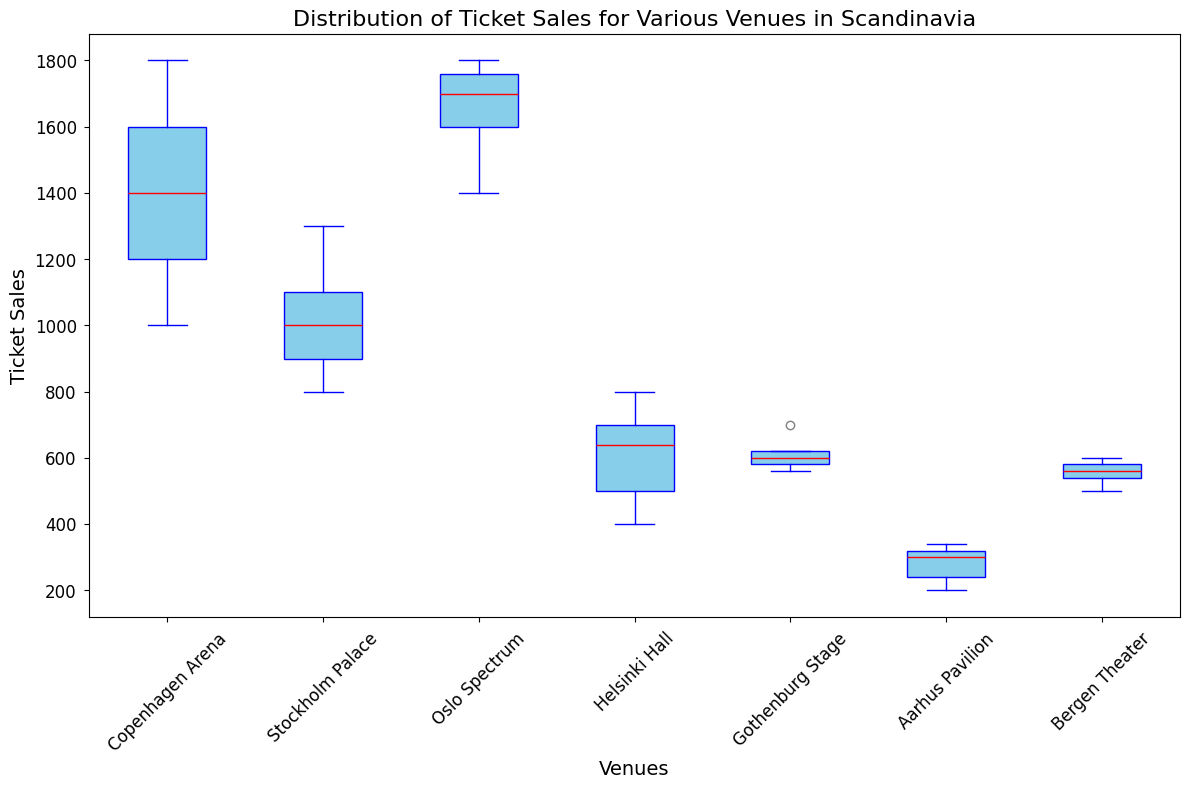Which venue has the highest median ticket sales? The median is indicated by the red line within each box plot. The Oslo Spectrum's median appears higher than all other venues.
Answer: Oslo Spectrum What is the range of ticket sales for Gothenburg Stage? The range is found by subtracting the minimum value (bottom whisker) from the maximum value (top whisker). For Gothenburg Stage, the values are approximately 980 to 1050, giving a range of 1050 - 980.
Answer: 70 Compare the interquartile range (IQR) of Copenhagen Arena to Aarhus Pavilion. Which is larger? The IQR is the length of the box itself, representing the range between the first quartile (Q1) and the third quartile (Q3). Copenhagen Arena has a larger box compared to Aarhus Pavilion, indicating a larger IQR.
Answer: Copenhagen Arena Are there any outliers in the ticket sales for Helsinki Hall? Outliers are indicated by orange markers outside the whiskers. There are no orange markers for Helsinki Hall, so there are no outliers.
Answer: No Which venue has the smallest variation in ticket sales? Variation can be inferred from the total length of the whiskers. The venue with the smallest total length of whiskers is Aarhus Pavilion.
Answer: Aarhus Pavilion Which venues have ticket sales that fall below 1000? By observing the bottom whisker or bottom edge of the box, we can see that Helsinki Hall, Gothenburg Stage, and Aarhus Pavilion all have points below 1000.
Answer: Helsinki Hall, Gothenburg Stage, Aarhus Pavilion Does Bergen Theater have a higher maximum ticket sale compared to Stockholm Palace? The top whisker of Bergen Theater extends to 1000, while Stockholm Palace extends to around 1350. Thus, Stockholm Palace has a higher maximum ticket sale.
Answer: No What are the average ticket sales for the Oslo Spectrum if we consider the median value as the central point? The median value (a red line) for Oslo Spectrum approximates around 1550. This is a central tendency measure, but it’s not necessarily the average. However, for simplicity, it gives a rough estimation.
Answer: 1550 Compare the ticket sales variability between Stockholm Palace and Bergen Theater. Which has a wider spread? By comparing the length of the whiskers, Stockholm Palace has a wider spread than Bergen Theater, indicating higher variability in ticket sales.
Answer: Stockholm Palace What can be inferred about the consistency in ticket sales at Aarhus Pavilion compared to other venues? Aarhus Pavilion shows a very narrow box with short whiskers, indicating highly consistent (low variability) ticket sales. This is in contrast to venues like Copenhagen Arena or Stockholm Palace with larger boxes and longer whiskers.
Answer: Highly consistent 